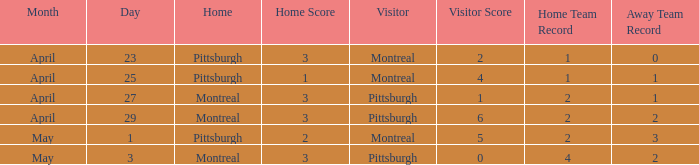Who visited on April 29? Pittsburgh. 